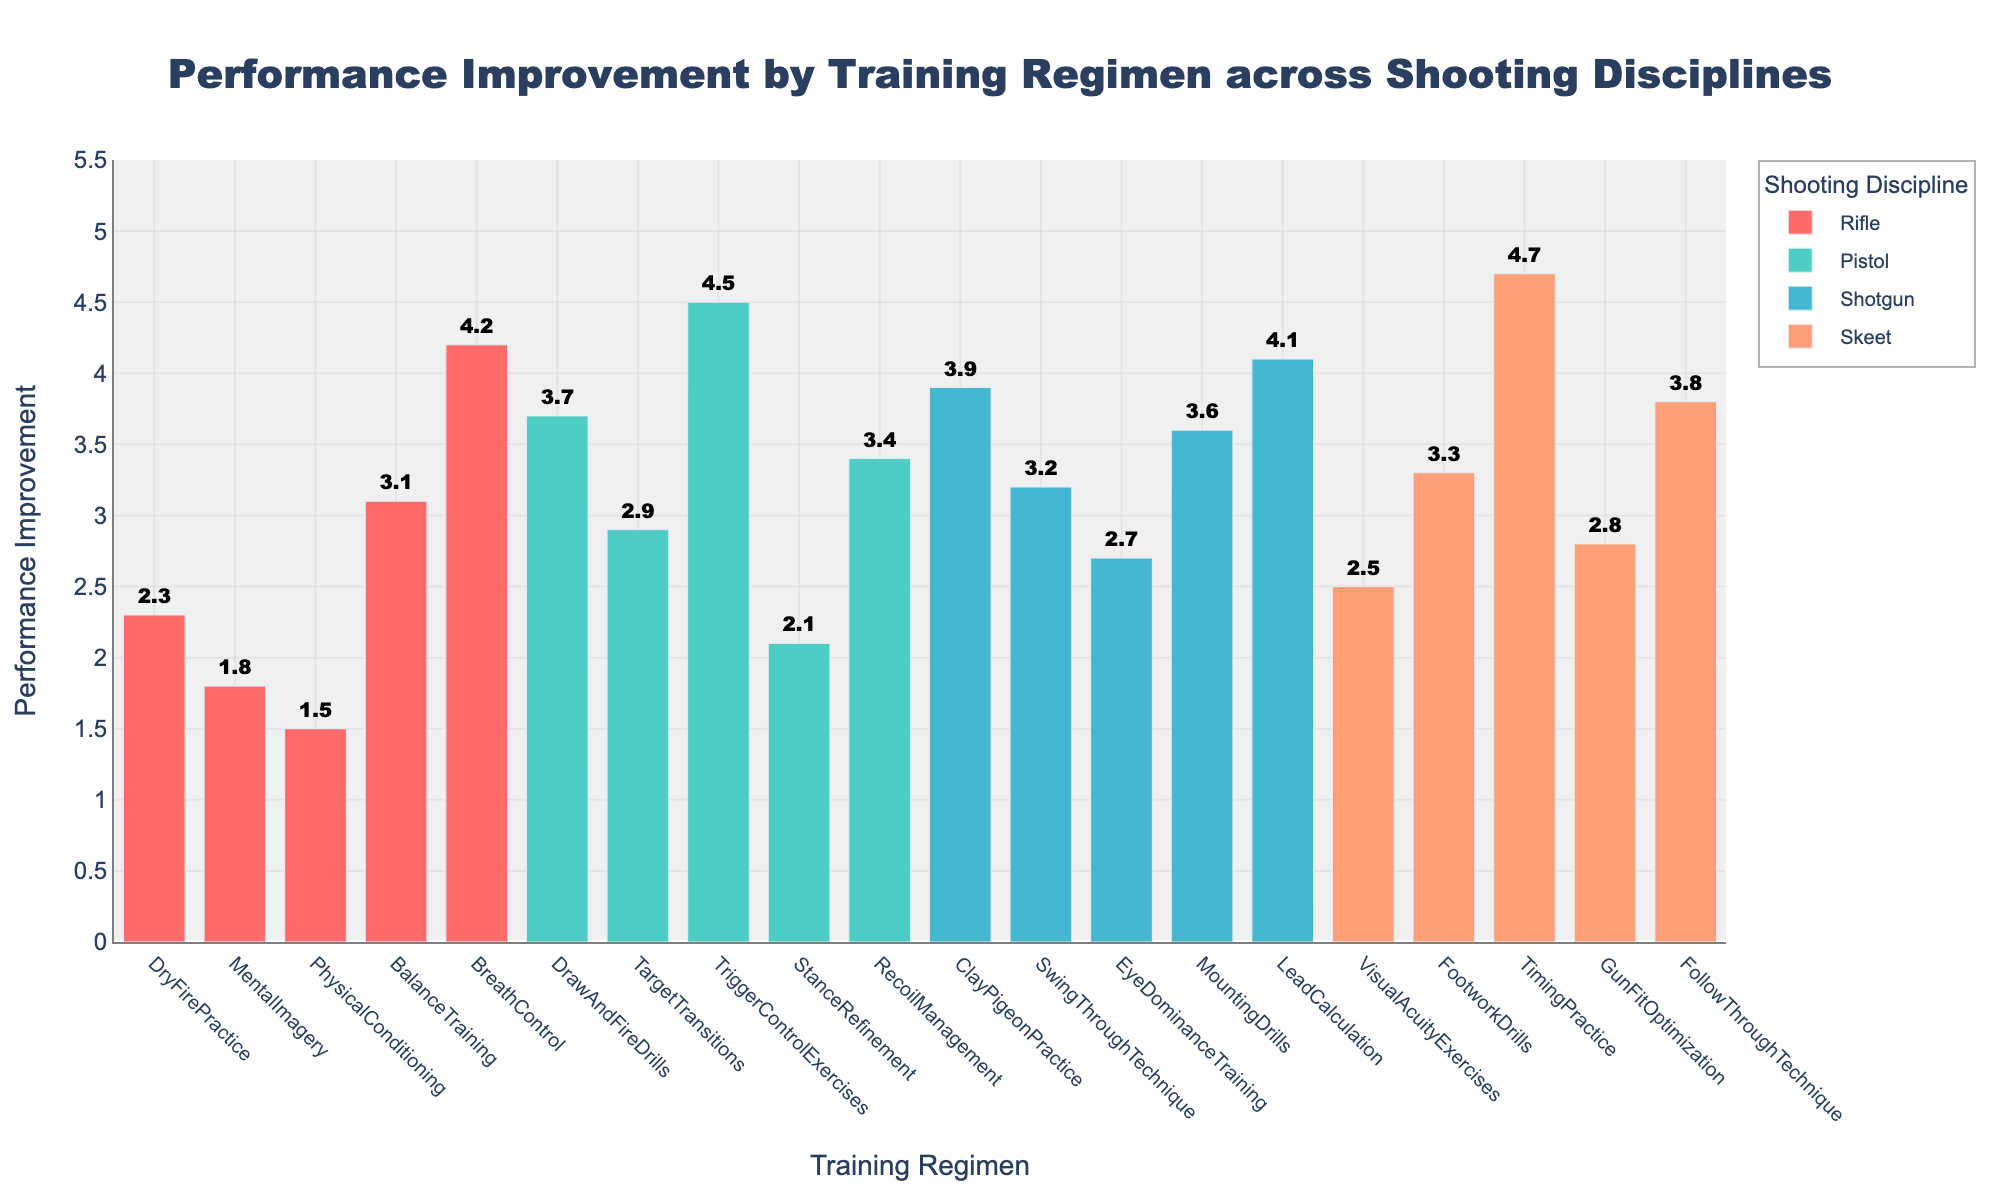what is the title of the figure? The title is located at the top of the figure, often in a larger and bolder font for emphasis. It summarizes the main insight of the visualization. Here, it reads "Performance Improvement by Training Regimen across Shooting Disciplines".
Answer: Performance Improvement by Training Regimen across Shooting Disciplines How many training regimens are shown for the Pistol discipline? Count the number of bars in the Pistol category, identified by the distinct color for Pistol. Each bar represents a training regimen.
Answer: 5 Which training regimen has the highest performance improvement overall? Identify the bar with the highest value on the Performance Improvement axis across all disciplines. This bar will indicate the highest performance improvement.
Answer: TimingPractice What is the average performance improvement for the Rifle discipline? Sum the performance improvements for all Rifle training regimens and divide by the number of regimens. For Rifle: (2.3 + 1.8 + 1.5 + 3.1 + 4.2) / 5.
Answer: 2.58 Which discipline shows the greatest range in performance improvement values? Calculate the range (difference between maximum and minimum values) for each discipline. Compare these ranges to find the greatest one.
Answer: Skeet How does BalanceTraining for Rifle compare in performance improvement to StanceRefinement for Pistol? Locate the performance improvement values for both BalanceTraining (Rifle) and StanceRefinement (Pistol) on the Performance Improvement axis and compare them directly.
Answer: BalanceTraining is higher Which regimen in the Skeet discipline has a similar performance improvement to TriggerControlExercises for Pistol? Find the performance improvement value for TriggerControlExercises in the Pistol discipline, then identify any regimen in the Skeet discipline with a similar value.
Answer: FollowThroughTechnique Is the performance improvement for BreathControl in Rifle greater than LeadCalculation in Shotgun? Compare the performance improvement values of BreathControl (Rifle) and LeadCalculation (Shotgun) directly on the y-axis.
Answer: No What is the median performance improvement for the Shotgun discipline? Sort the Shotgun performance improvements in ascending order and find the middle value or the average of the two middle values. For Shotgun: 2.7, 3.2, 3.6, 3.9, 4.1, median is 3.6.
Answer: 3.6 How much higher is the highest value for Pistol compared to the highest value for Rifle? Identify the highest performance improvement values for both Pistol and Rifle, then subtract the highest Rifle value from the highest Pistol value. For Pistol: 4.5, Rifle: 4.2, so 4.5 - 4.2.
Answer: 0.3 